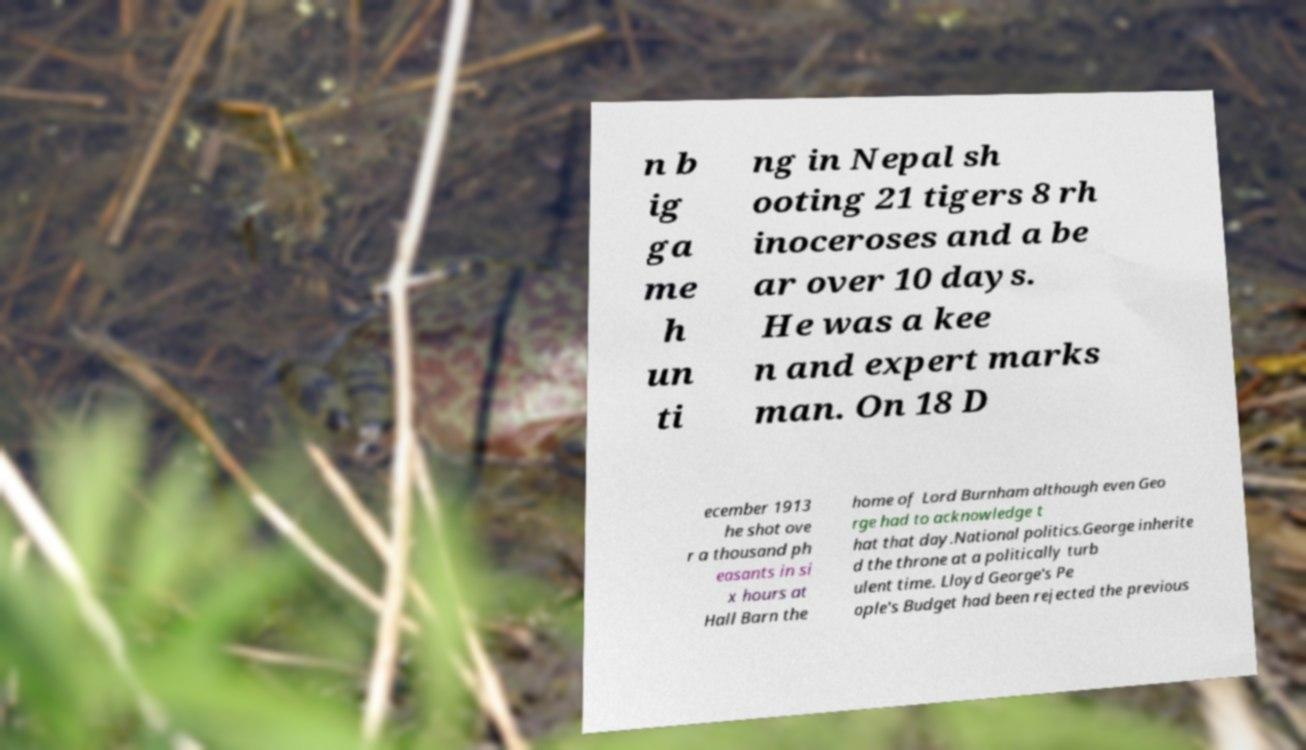Please identify and transcribe the text found in this image. n b ig ga me h un ti ng in Nepal sh ooting 21 tigers 8 rh inoceroses and a be ar over 10 days. He was a kee n and expert marks man. On 18 D ecember 1913 he shot ove r a thousand ph easants in si x hours at Hall Barn the home of Lord Burnham although even Geo rge had to acknowledge t hat that day.National politics.George inherite d the throne at a politically turb ulent time. Lloyd George's Pe ople's Budget had been rejected the previous 